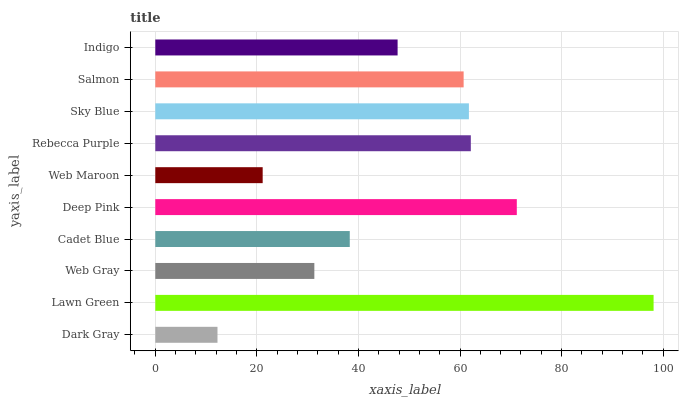Is Dark Gray the minimum?
Answer yes or no. Yes. Is Lawn Green the maximum?
Answer yes or no. Yes. Is Web Gray the minimum?
Answer yes or no. No. Is Web Gray the maximum?
Answer yes or no. No. Is Lawn Green greater than Web Gray?
Answer yes or no. Yes. Is Web Gray less than Lawn Green?
Answer yes or no. Yes. Is Web Gray greater than Lawn Green?
Answer yes or no. No. Is Lawn Green less than Web Gray?
Answer yes or no. No. Is Salmon the high median?
Answer yes or no. Yes. Is Indigo the low median?
Answer yes or no. Yes. Is Web Maroon the high median?
Answer yes or no. No. Is Sky Blue the low median?
Answer yes or no. No. 